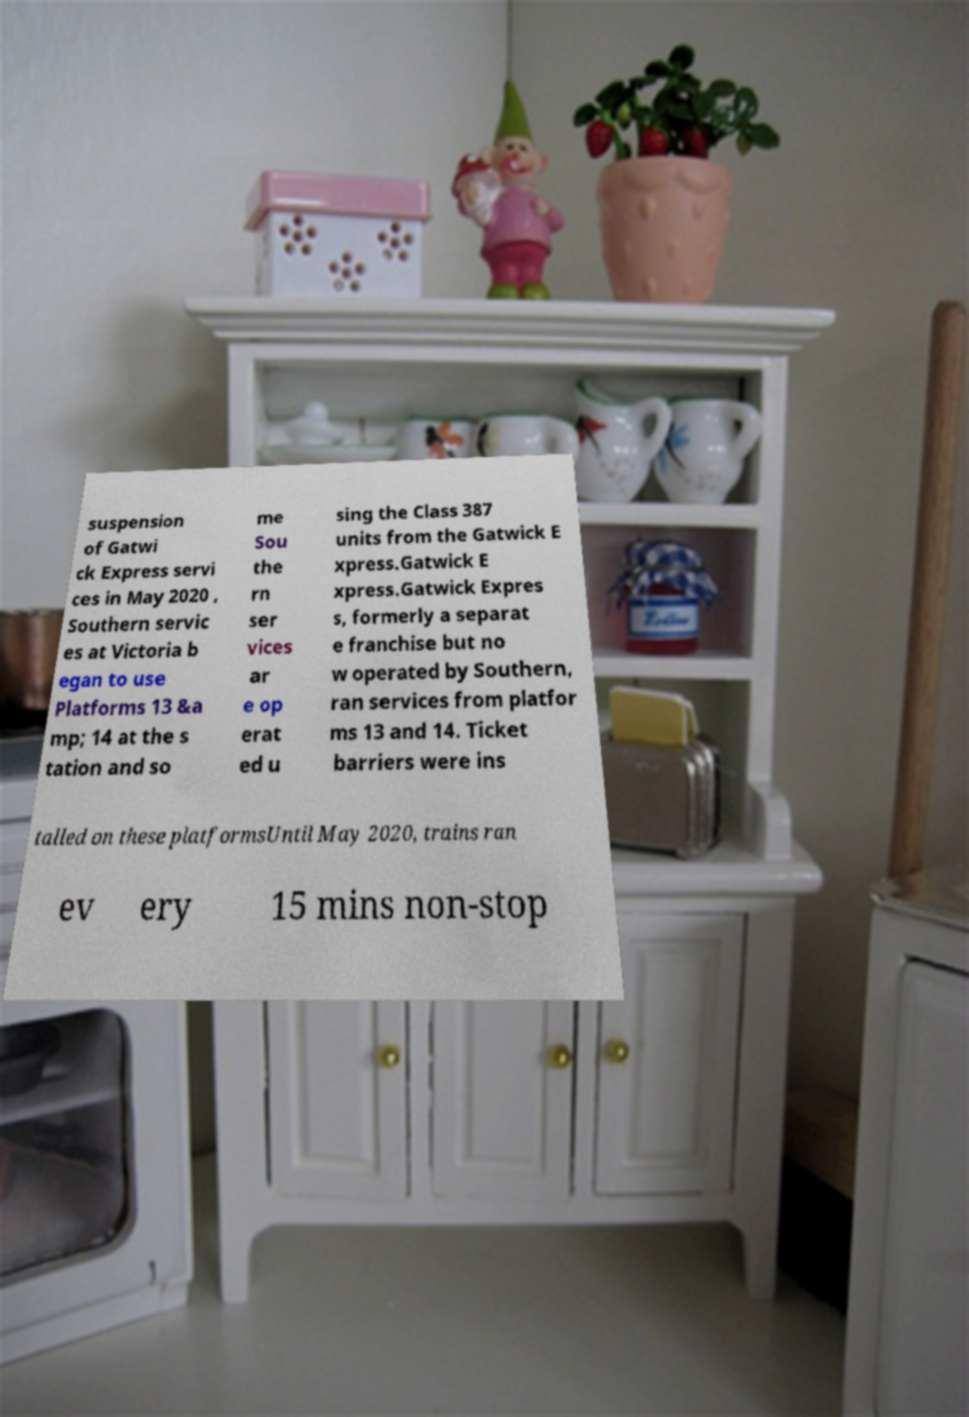For documentation purposes, I need the text within this image transcribed. Could you provide that? suspension of Gatwi ck Express servi ces in May 2020 , Southern servic es at Victoria b egan to use Platforms 13 &a mp; 14 at the s tation and so me Sou the rn ser vices ar e op erat ed u sing the Class 387 units from the Gatwick E xpress.Gatwick E xpress.Gatwick Expres s, formerly a separat e franchise but no w operated by Southern, ran services from platfor ms 13 and 14. Ticket barriers were ins talled on these platformsUntil May 2020, trains ran ev ery 15 mins non-stop 